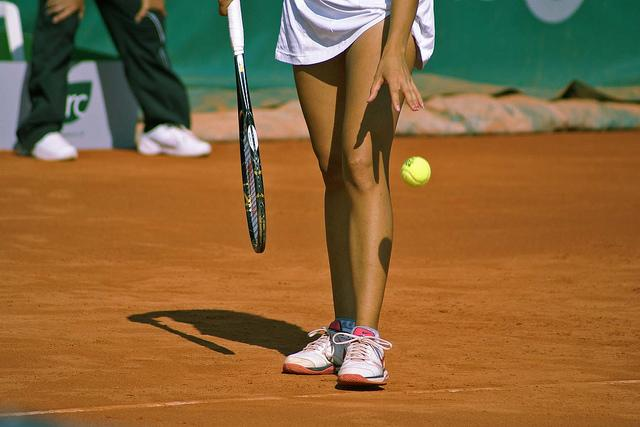What will the person here do next in the game? Please explain your reasoning. serve. The player serving often bounce the ball before serving. 